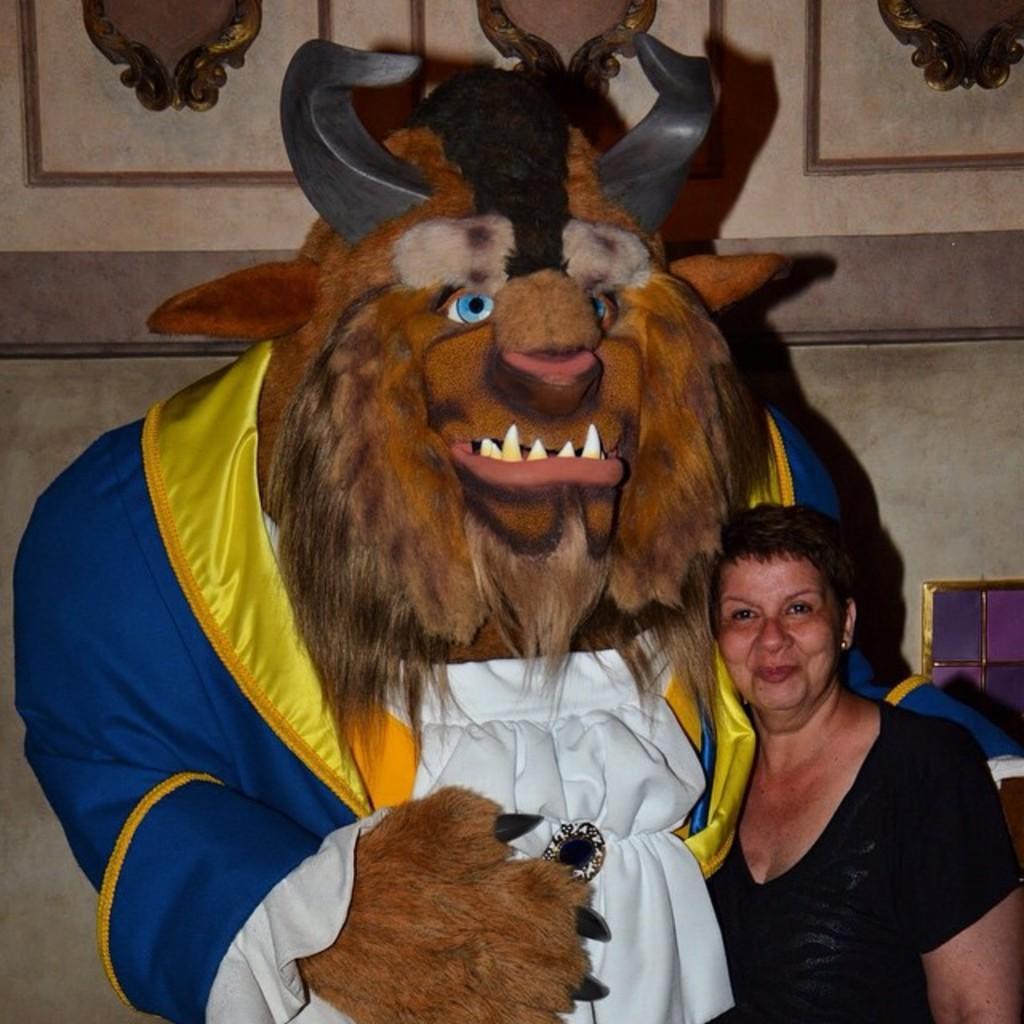How would you summarize this image in a sentence or two? There is a woman in black color t-shirt smiling and standing near a statue. In the background, there is a wall. 